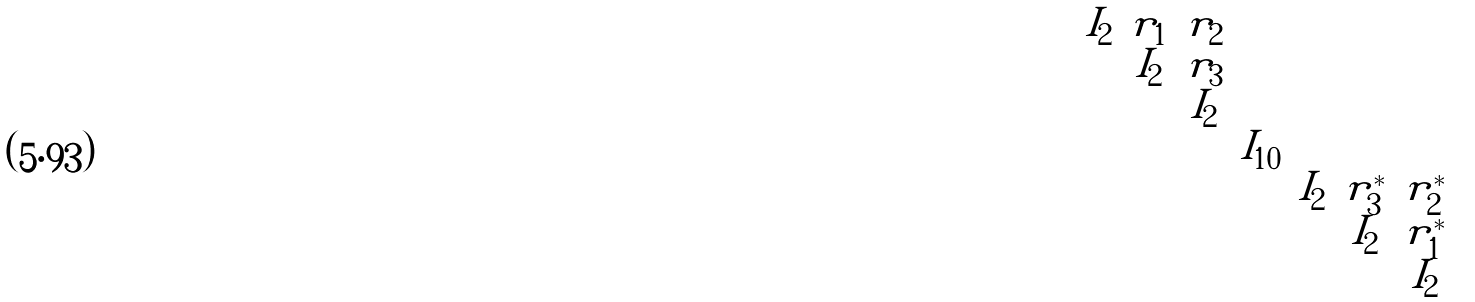Convert formula to latex. <formula><loc_0><loc_0><loc_500><loc_500>\begin{pmatrix} I _ { 2 } & r _ { 1 } & r _ { 2 } & & & & \\ & I _ { 2 } & r _ { 3 } & & & & \\ & & I _ { 2 } & & & & \\ & & & I _ { 1 0 } & & & \\ & & & & I _ { 2 } & r _ { 3 } ^ { * } & r _ { 2 } ^ { * } \\ & & & & & I _ { 2 } & r _ { 1 } ^ { * } \\ & & & & & & I _ { 2 } \end{pmatrix}</formula> 